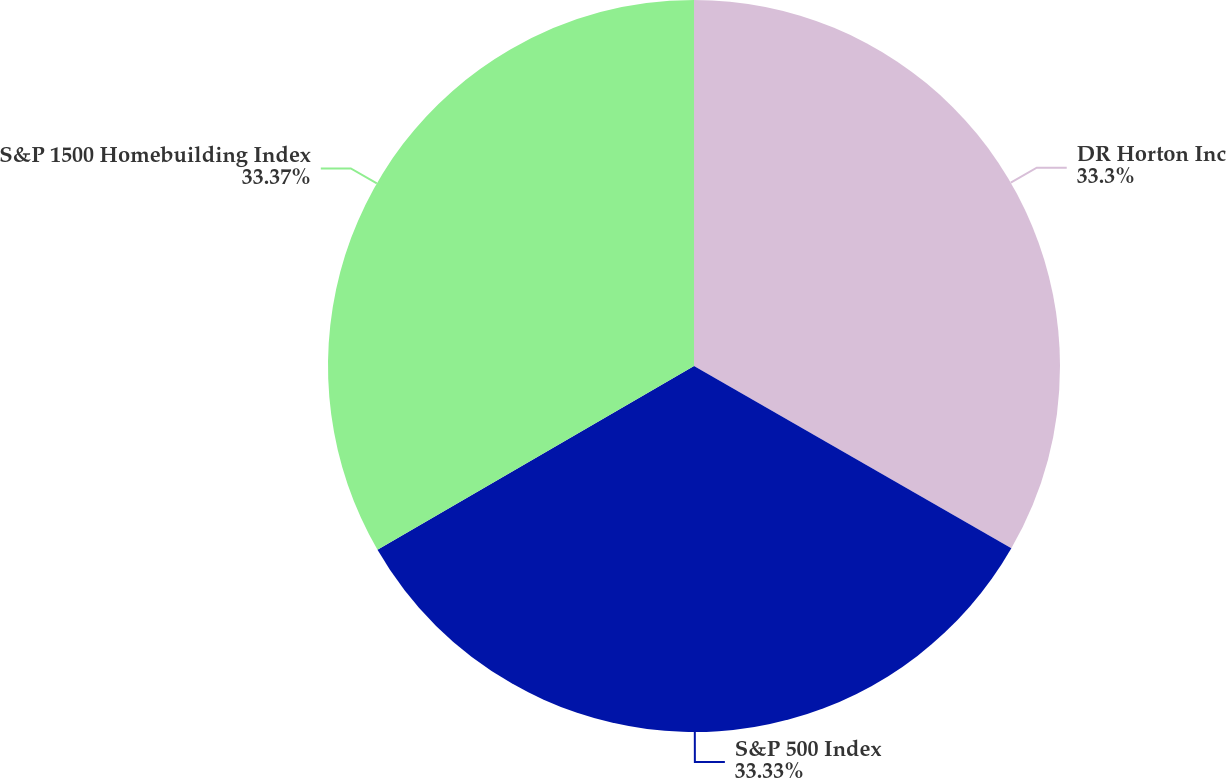Convert chart to OTSL. <chart><loc_0><loc_0><loc_500><loc_500><pie_chart><fcel>DR Horton Inc<fcel>S&P 500 Index<fcel>S&P 1500 Homebuilding Index<nl><fcel>33.3%<fcel>33.33%<fcel>33.37%<nl></chart> 